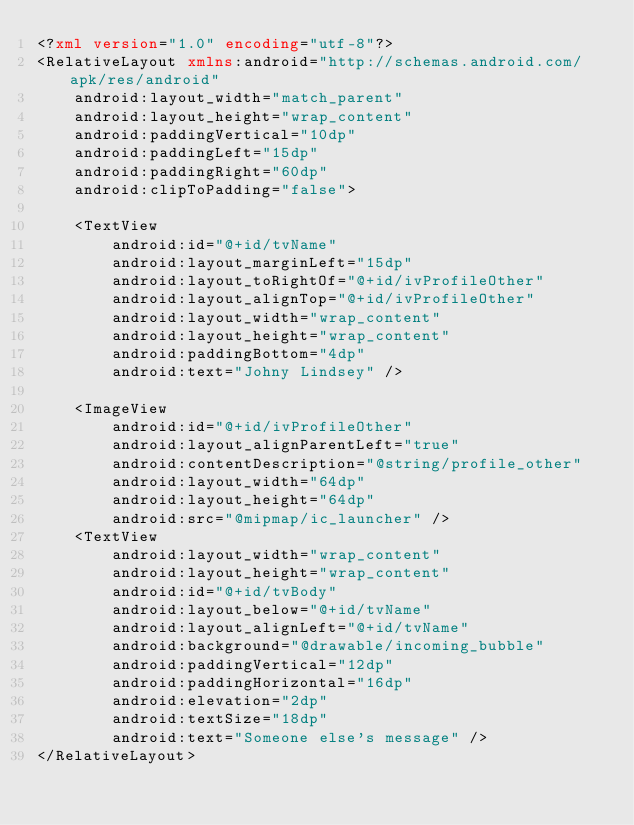Convert code to text. <code><loc_0><loc_0><loc_500><loc_500><_XML_><?xml version="1.0" encoding="utf-8"?>
<RelativeLayout xmlns:android="http://schemas.android.com/apk/res/android"
    android:layout_width="match_parent"
    android:layout_height="wrap_content"
    android:paddingVertical="10dp"
    android:paddingLeft="15dp"
    android:paddingRight="60dp"
    android:clipToPadding="false">

    <TextView
        android:id="@+id/tvName"
        android:layout_marginLeft="15dp"
        android:layout_toRightOf="@+id/ivProfileOther"
        android:layout_alignTop="@+id/ivProfileOther"
        android:layout_width="wrap_content"
        android:layout_height="wrap_content"
        android:paddingBottom="4dp"
        android:text="Johny Lindsey" />

    <ImageView
        android:id="@+id/ivProfileOther"
        android:layout_alignParentLeft="true"
        android:contentDescription="@string/profile_other"
        android:layout_width="64dp"
        android:layout_height="64dp"
        android:src="@mipmap/ic_launcher" />
    <TextView
        android:layout_width="wrap_content"
        android:layout_height="wrap_content"
        android:id="@+id/tvBody"
        android:layout_below="@+id/tvName"
        android:layout_alignLeft="@+id/tvName"
        android:background="@drawable/incoming_bubble"
        android:paddingVertical="12dp"
        android:paddingHorizontal="16dp"
        android:elevation="2dp"
        android:textSize="18dp"
        android:text="Someone else's message" />
</RelativeLayout></code> 